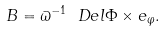Convert formula to latex. <formula><loc_0><loc_0><loc_500><loc_500>B = \varpi ^ { - 1 } \ D e l \Phi \times e _ { \varphi } .</formula> 